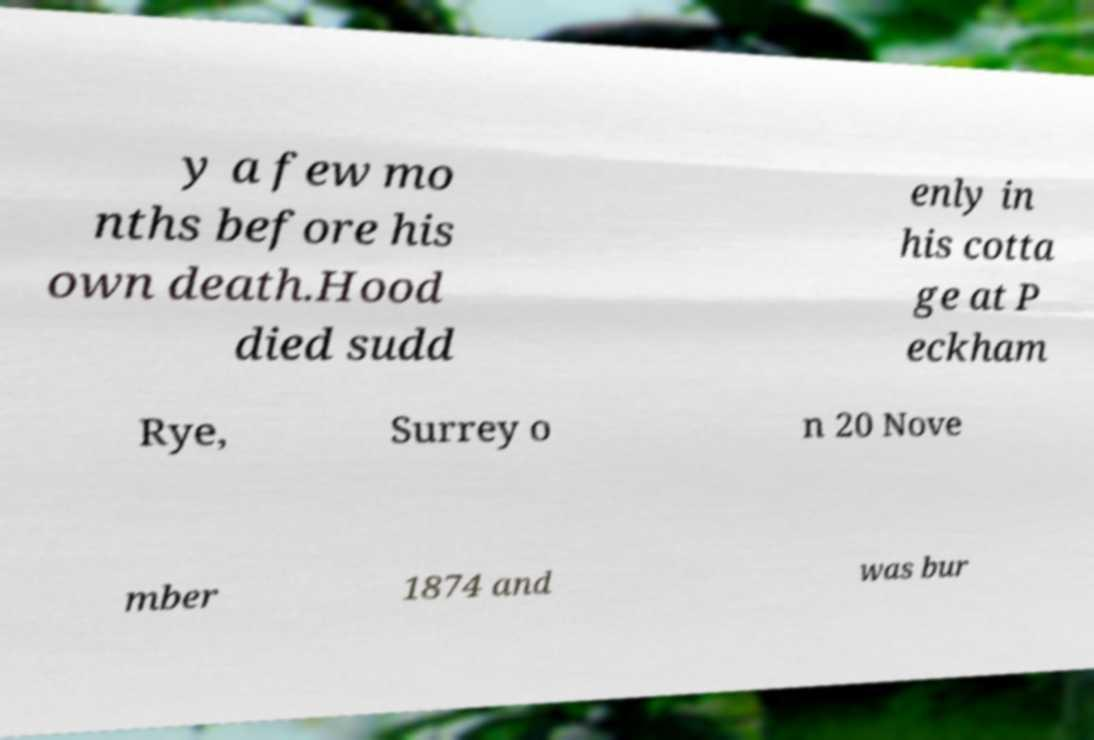What messages or text are displayed in this image? I need them in a readable, typed format. y a few mo nths before his own death.Hood died sudd enly in his cotta ge at P eckham Rye, Surrey o n 20 Nove mber 1874 and was bur 